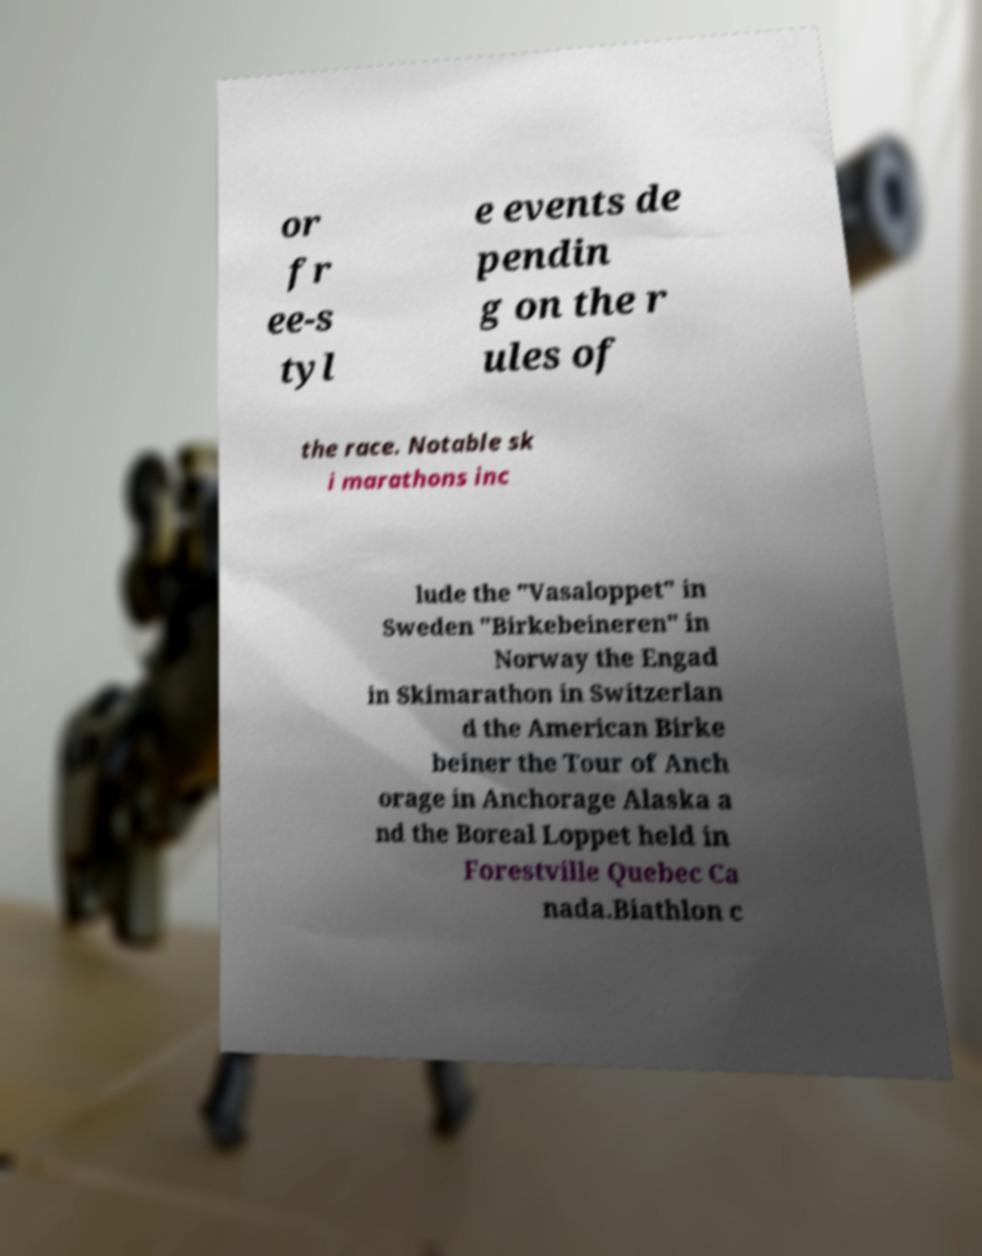Can you read and provide the text displayed in the image?This photo seems to have some interesting text. Can you extract and type it out for me? or fr ee-s tyl e events de pendin g on the r ules of the race. Notable sk i marathons inc lude the "Vasaloppet" in Sweden "Birkebeineren" in Norway the Engad in Skimarathon in Switzerlan d the American Birke beiner the Tour of Anch orage in Anchorage Alaska a nd the Boreal Loppet held in Forestville Quebec Ca nada.Biathlon c 